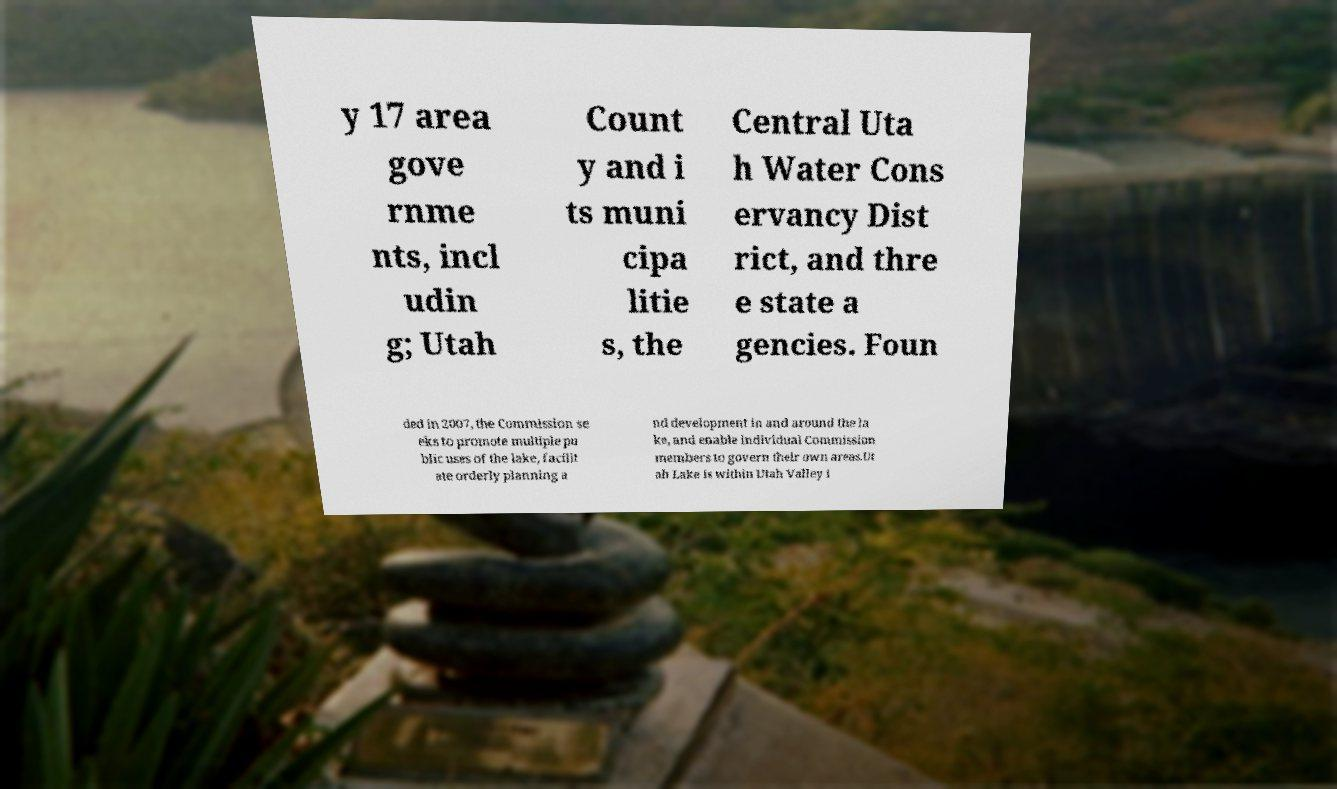Please identify and transcribe the text found in this image. y 17 area gove rnme nts, incl udin g; Utah Count y and i ts muni cipa litie s, the Central Uta h Water Cons ervancy Dist rict, and thre e state a gencies. Foun ded in 2007, the Commission se eks to promote multiple pu blic uses of the lake, facilit ate orderly planning a nd development in and around the la ke, and enable individual Commission members to govern their own areas.Ut ah Lake is within Utah Valley i 